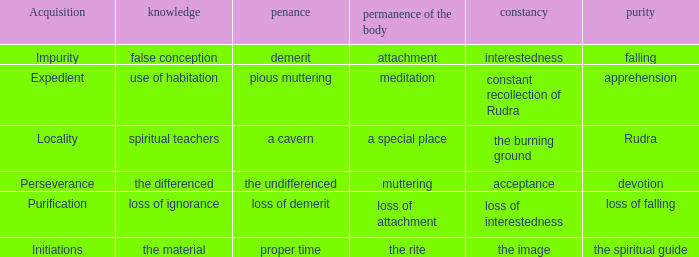In what way is the body's enduring nature connected to the unchanging state of attentiveness? Attachment. 